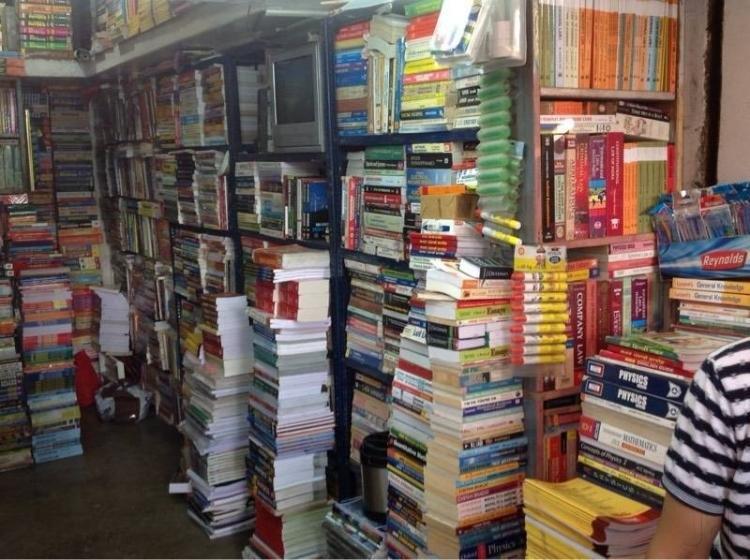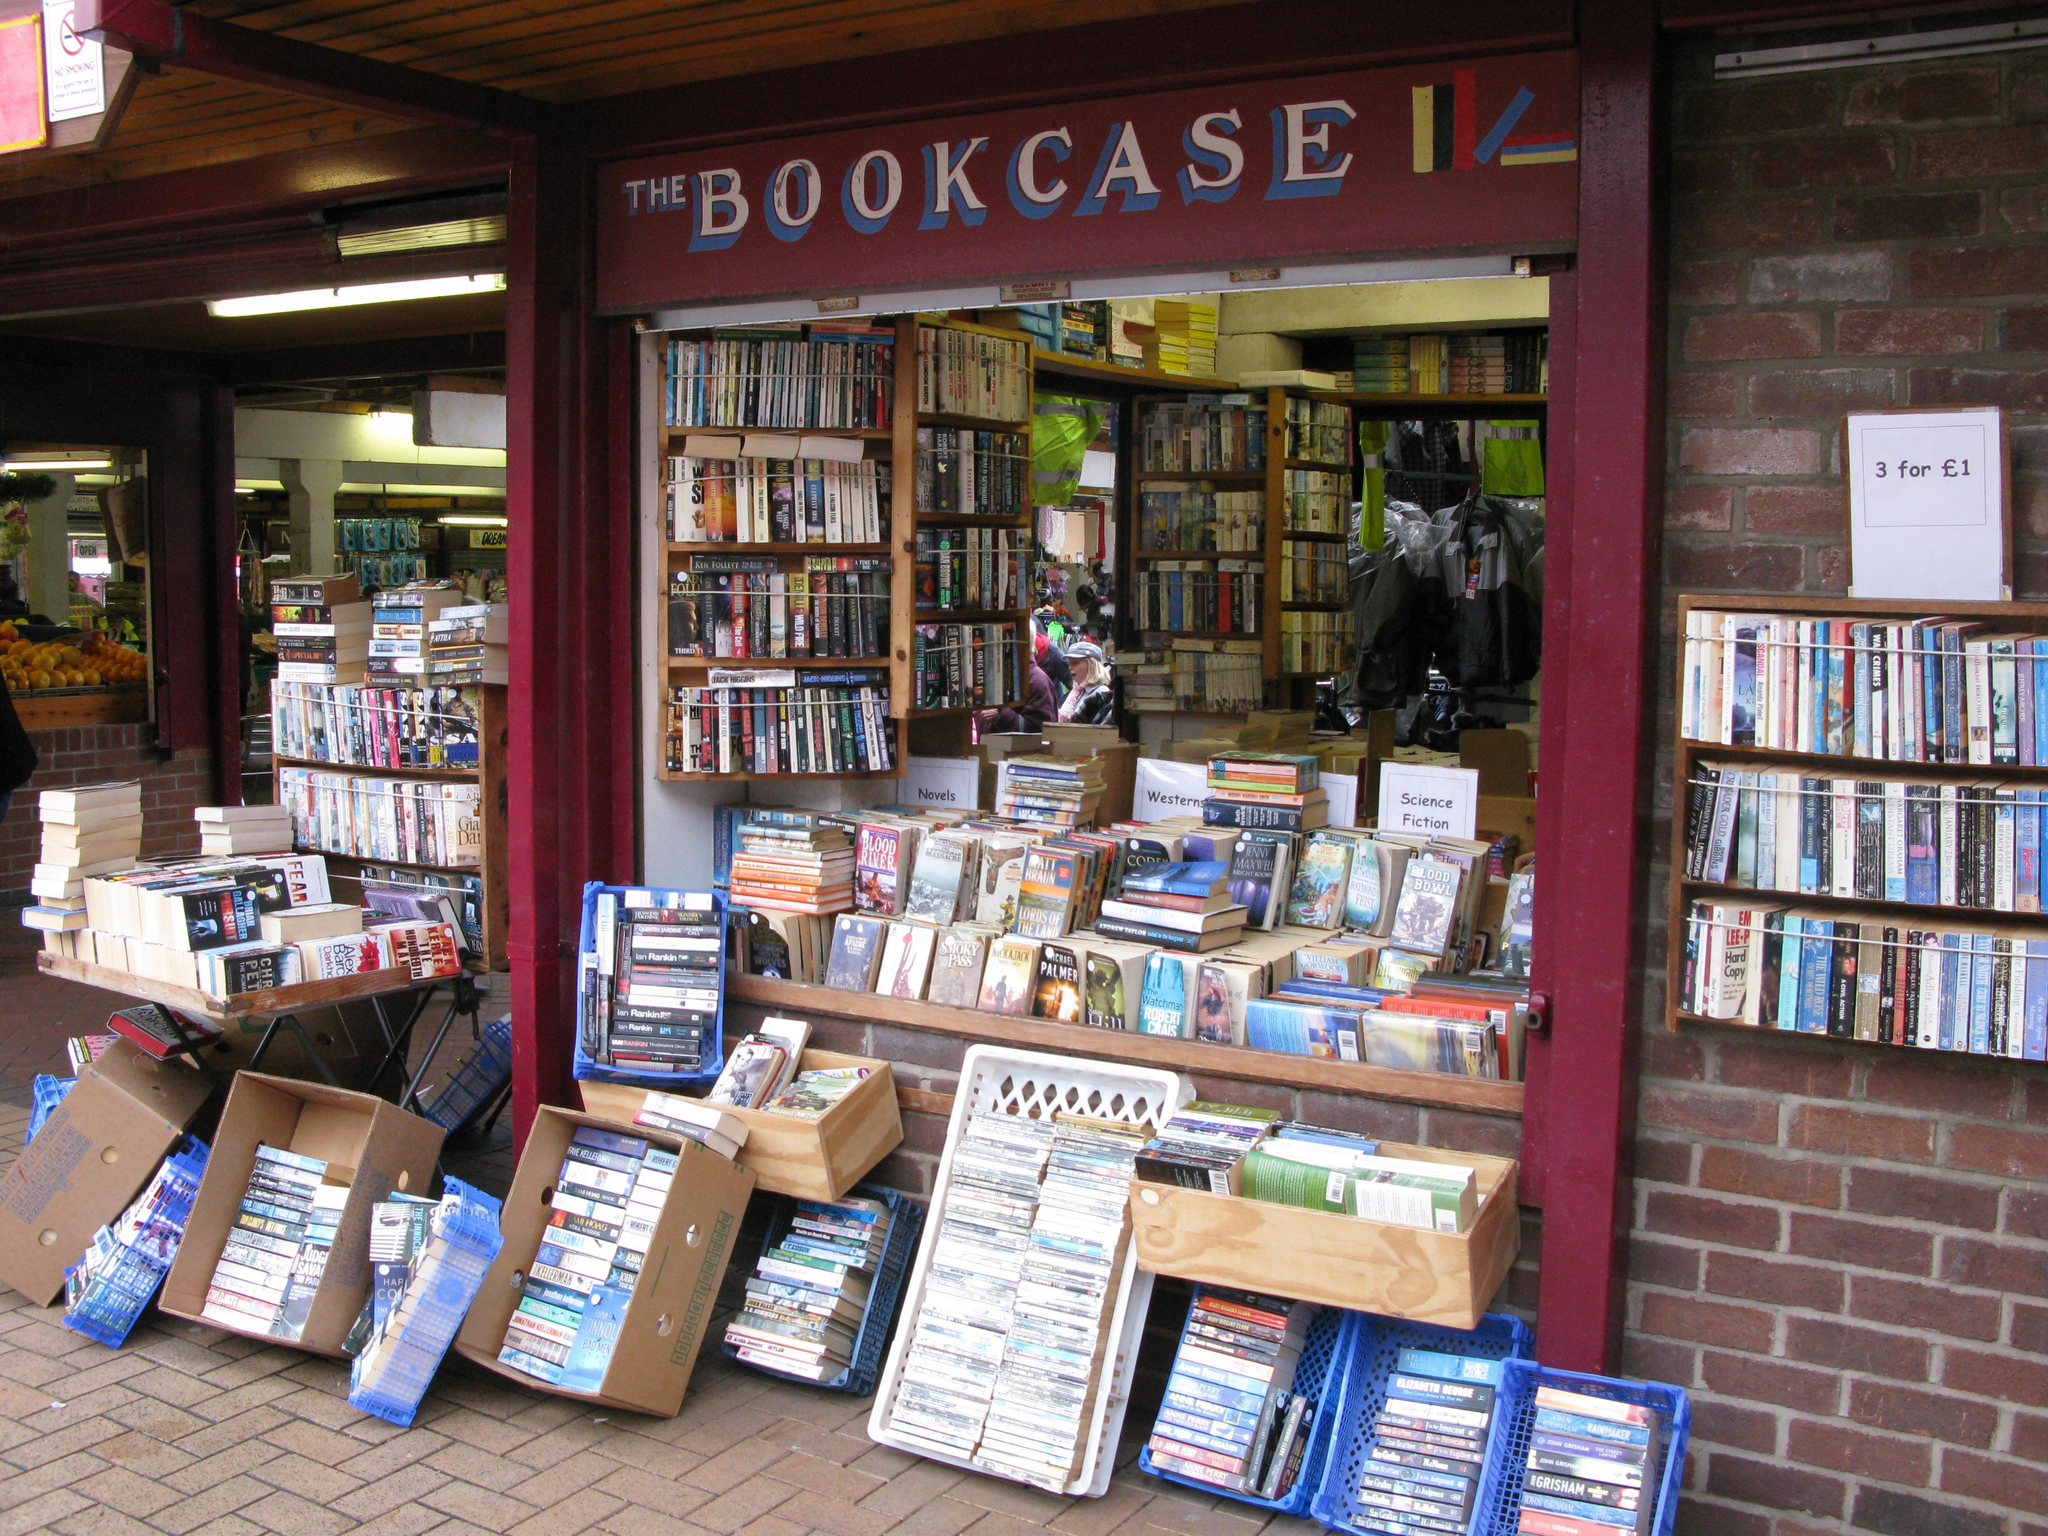The first image is the image on the left, the second image is the image on the right. Evaluate the accuracy of this statement regarding the images: "One of the stores is Modern Book Shop.". Is it true? Answer yes or no. No. 